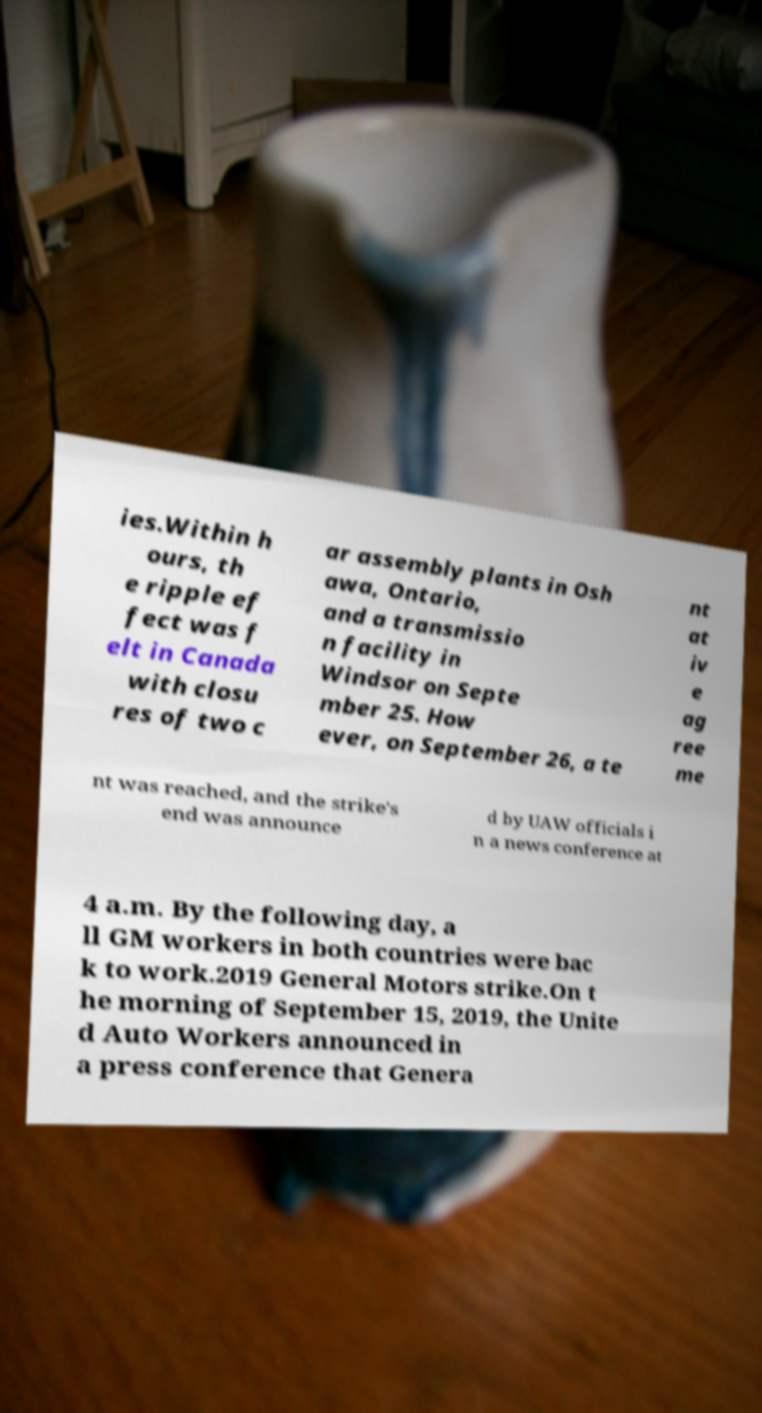Could you extract and type out the text from this image? ies.Within h ours, th e ripple ef fect was f elt in Canada with closu res of two c ar assembly plants in Osh awa, Ontario, and a transmissio n facility in Windsor on Septe mber 25. How ever, on September 26, a te nt at iv e ag ree me nt was reached, and the strike's end was announce d by UAW officials i n a news conference at 4 a.m. By the following day, a ll GM workers in both countries were bac k to work.2019 General Motors strike.On t he morning of September 15, 2019, the Unite d Auto Workers announced in a press conference that Genera 